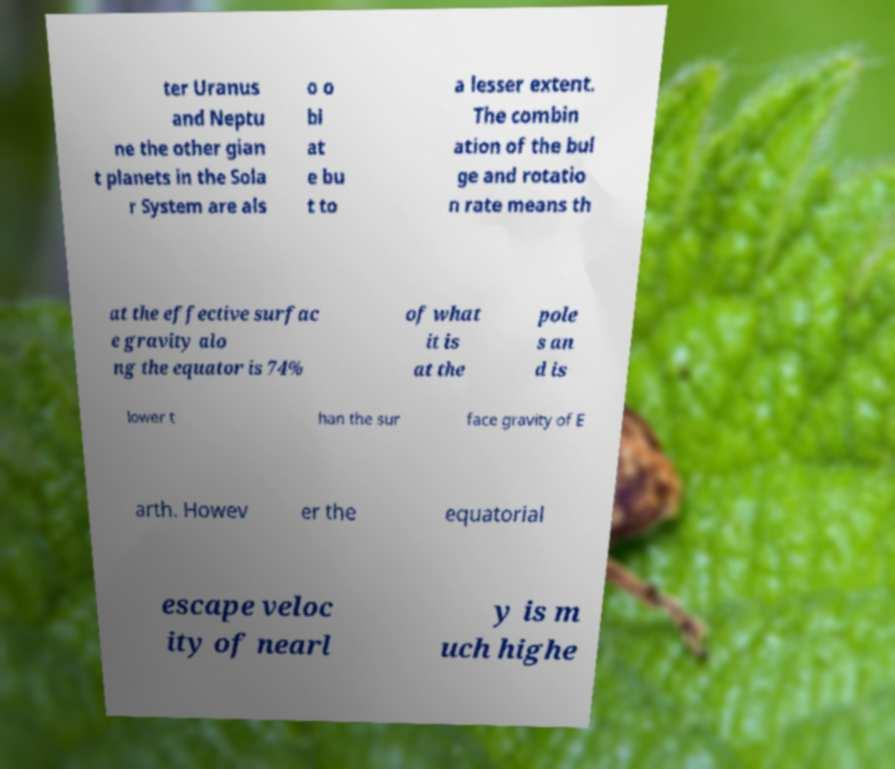Can you read and provide the text displayed in the image?This photo seems to have some interesting text. Can you extract and type it out for me? ter Uranus and Neptu ne the other gian t planets in the Sola r System are als o o bl at e bu t to a lesser extent. The combin ation of the bul ge and rotatio n rate means th at the effective surfac e gravity alo ng the equator is 74% of what it is at the pole s an d is lower t han the sur face gravity of E arth. Howev er the equatorial escape veloc ity of nearl y is m uch highe 